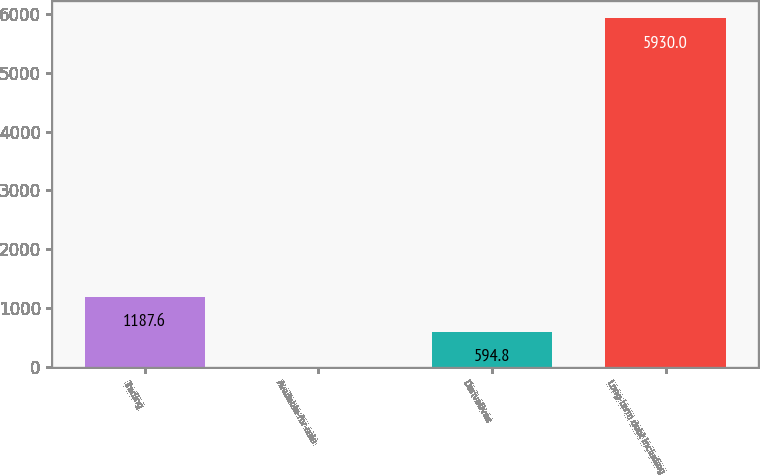Convert chart to OTSL. <chart><loc_0><loc_0><loc_500><loc_500><bar_chart><fcel>Trading<fcel>Available-for-sale<fcel>Derivatives<fcel>Long-term debt including<nl><fcel>1187.6<fcel>2<fcel>594.8<fcel>5930<nl></chart> 